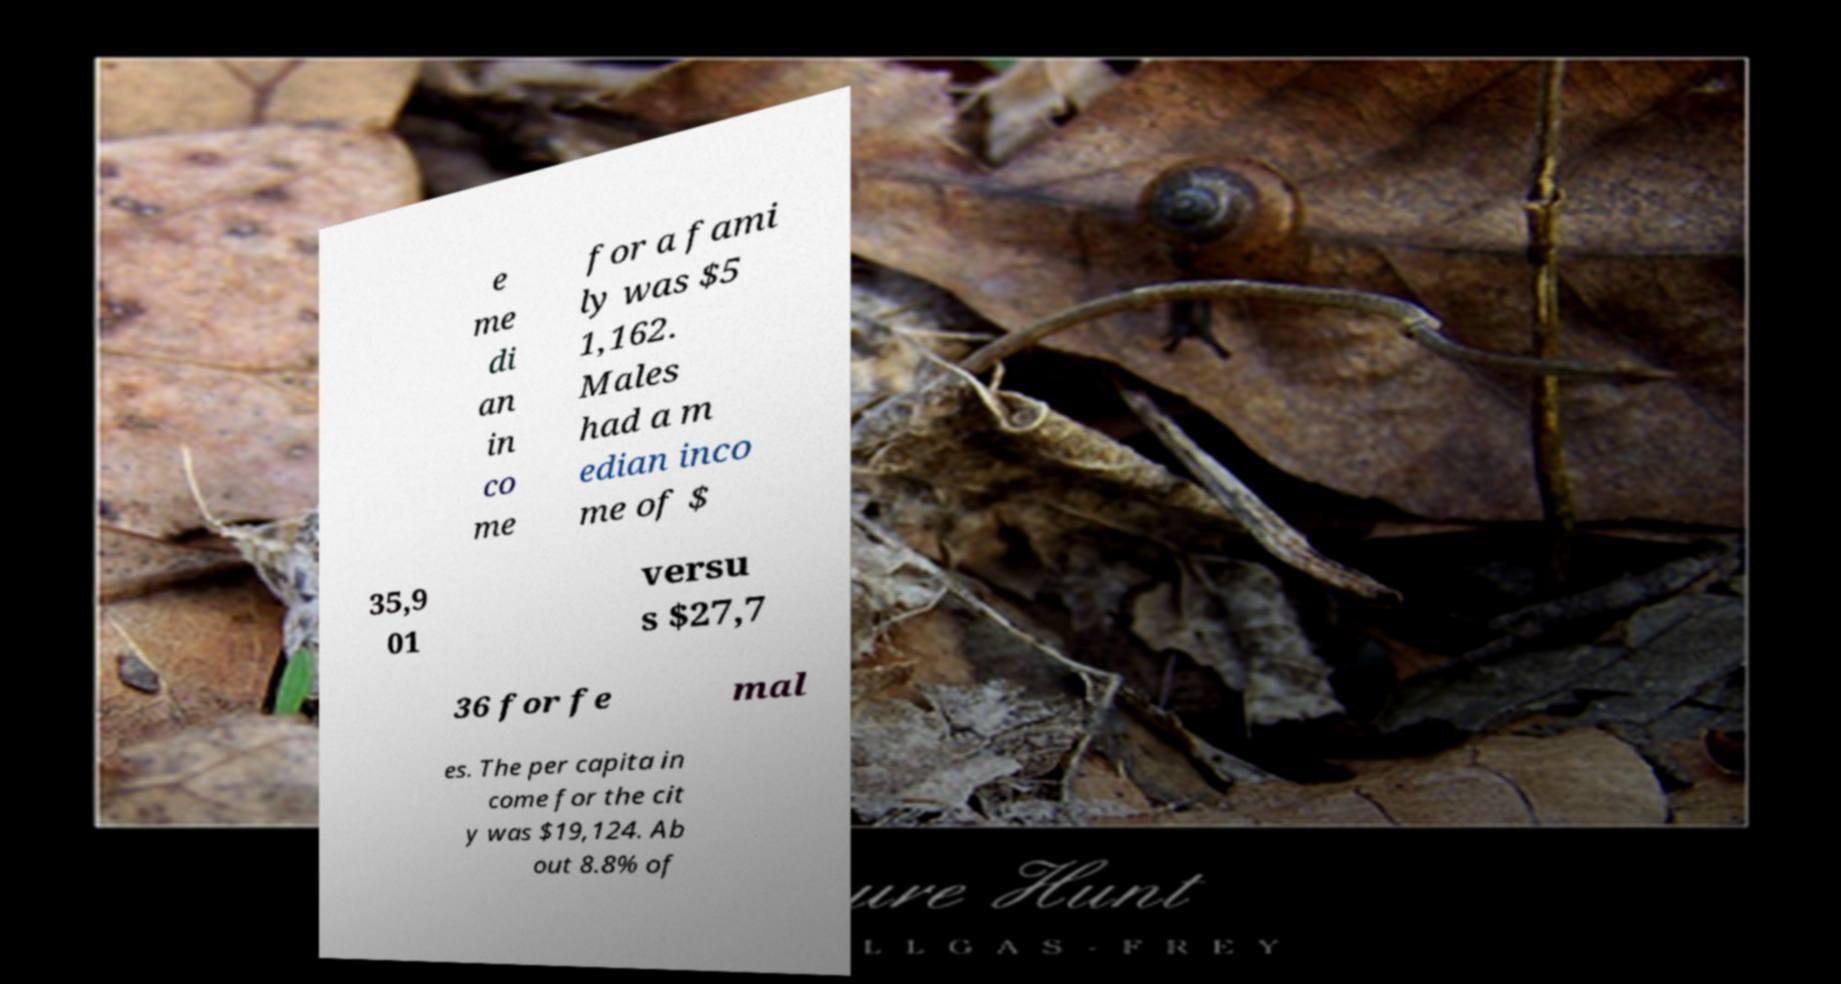Please read and relay the text visible in this image. What does it say? e me di an in co me for a fami ly was $5 1,162. Males had a m edian inco me of $ 35,9 01 versu s $27,7 36 for fe mal es. The per capita in come for the cit y was $19,124. Ab out 8.8% of 